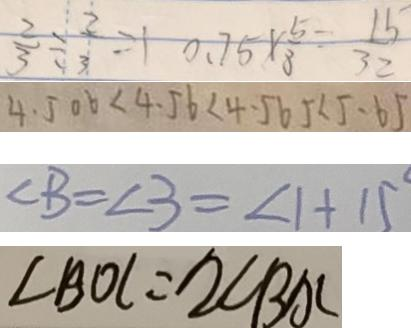Convert formula to latex. <formula><loc_0><loc_0><loc_500><loc_500>\frac { 2 } { 3 } \div \frac { 2 } { 3 } = 1 0 . 7 5 \times \frac { 5 } { 8 } = \frac { 1 5 } { 3 2 } 
 4 . 5 0 6 < 4 . 5 6 < 4 . 5 6 5 < 5 . 6 5 
 \angle B = \angle 3 = \angle 1 + 1 5 ^ { \circ } 
 \angle B O C = 2 \angle B A C</formula> 